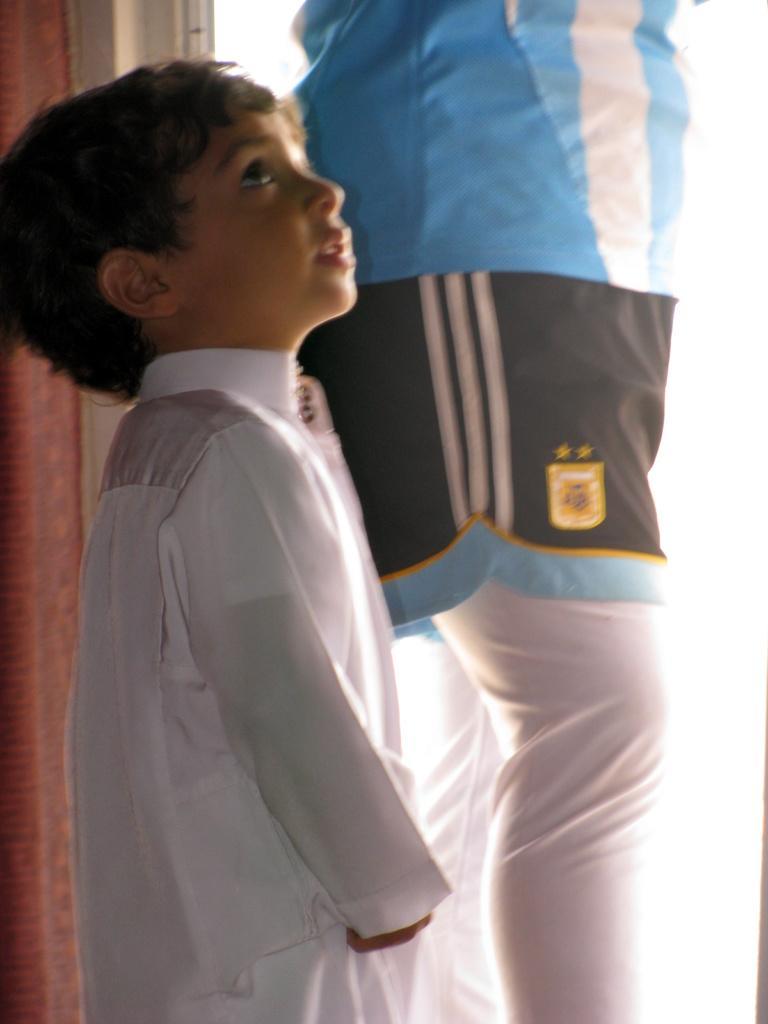In one or two sentences, can you explain what this image depicts? In the center of the image we can see man and boy are standing. In the background of the image we can see wall, door are there. 